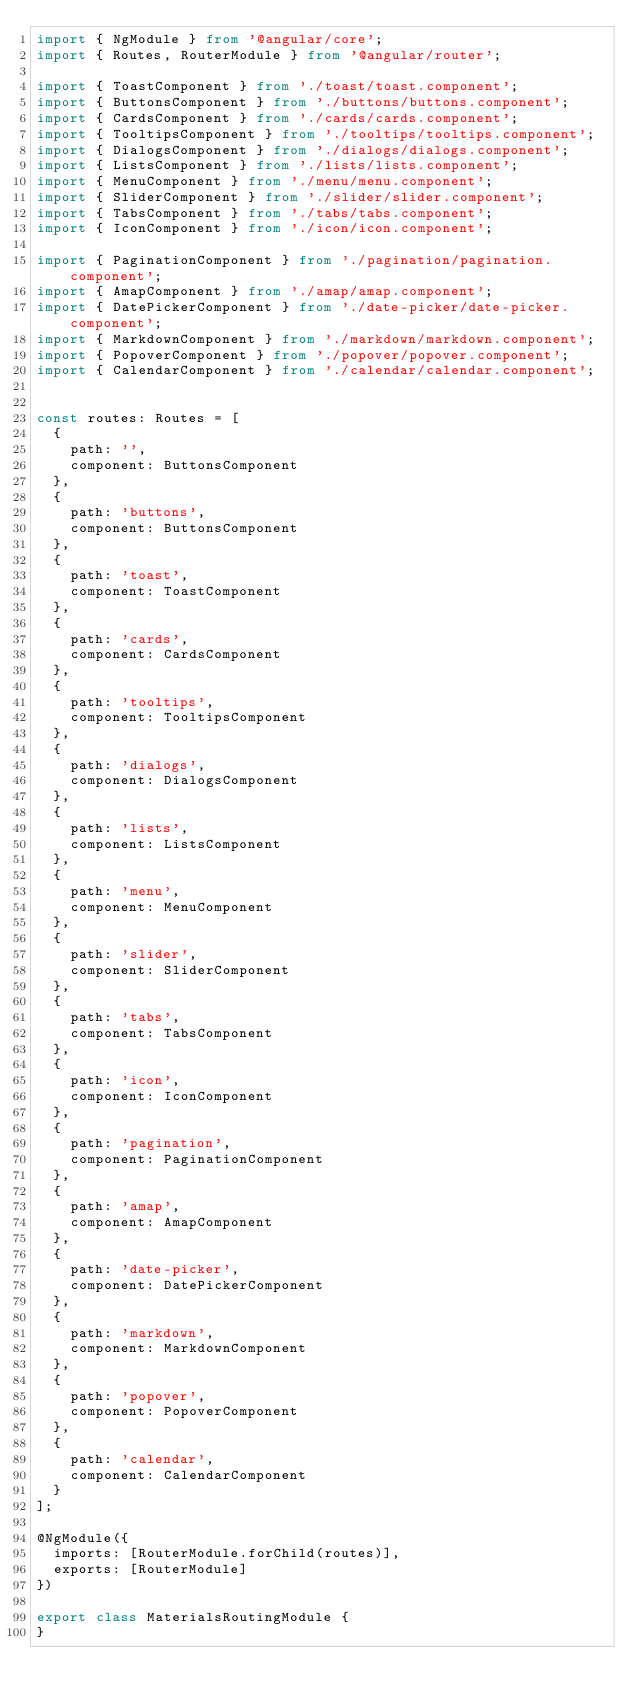<code> <loc_0><loc_0><loc_500><loc_500><_TypeScript_>import { NgModule } from '@angular/core';
import { Routes, RouterModule } from '@angular/router';

import { ToastComponent } from './toast/toast.component';
import { ButtonsComponent } from './buttons/buttons.component';
import { CardsComponent } from './cards/cards.component';
import { TooltipsComponent } from './tooltips/tooltips.component';
import { DialogsComponent } from './dialogs/dialogs.component';
import { ListsComponent } from './lists/lists.component';
import { MenuComponent } from './menu/menu.component';
import { SliderComponent } from './slider/slider.component';
import { TabsComponent } from './tabs/tabs.component';
import { IconComponent } from './icon/icon.component';

import { PaginationComponent } from './pagination/pagination.component';
import { AmapComponent } from './amap/amap.component';
import { DatePickerComponent } from './date-picker/date-picker.component';
import { MarkdownComponent } from './markdown/markdown.component';
import { PopoverComponent } from './popover/popover.component';
import { CalendarComponent } from './calendar/calendar.component';


const routes: Routes = [
  {
    path: '',
    component: ButtonsComponent
  },
  {
    path: 'buttons',
    component: ButtonsComponent
  },
  {
    path: 'toast',
    component: ToastComponent
  },
  {
    path: 'cards',
    component: CardsComponent
  },
  {
    path: 'tooltips',
    component: TooltipsComponent
  },
  {
    path: 'dialogs',
    component: DialogsComponent
  },
  {
    path: 'lists',
    component: ListsComponent
  },
  {
    path: 'menu',
    component: MenuComponent
  },
  {
    path: 'slider',
    component: SliderComponent
  },
  {
    path: 'tabs',
    component: TabsComponent
  },
  {
    path: 'icon',
    component: IconComponent
  },
  {
    path: 'pagination',
    component: PaginationComponent
  },
  {
    path: 'amap',
    component: AmapComponent
  },
  {
    path: 'date-picker',
    component: DatePickerComponent
  },
  {
    path: 'markdown',
    component: MarkdownComponent
  },
  {
    path: 'popover',
    component: PopoverComponent
  },
  {
    path: 'calendar',
    component: CalendarComponent
  }
];

@NgModule({
  imports: [RouterModule.forChild(routes)],
  exports: [RouterModule]
})

export class MaterialsRoutingModule {
}
</code> 